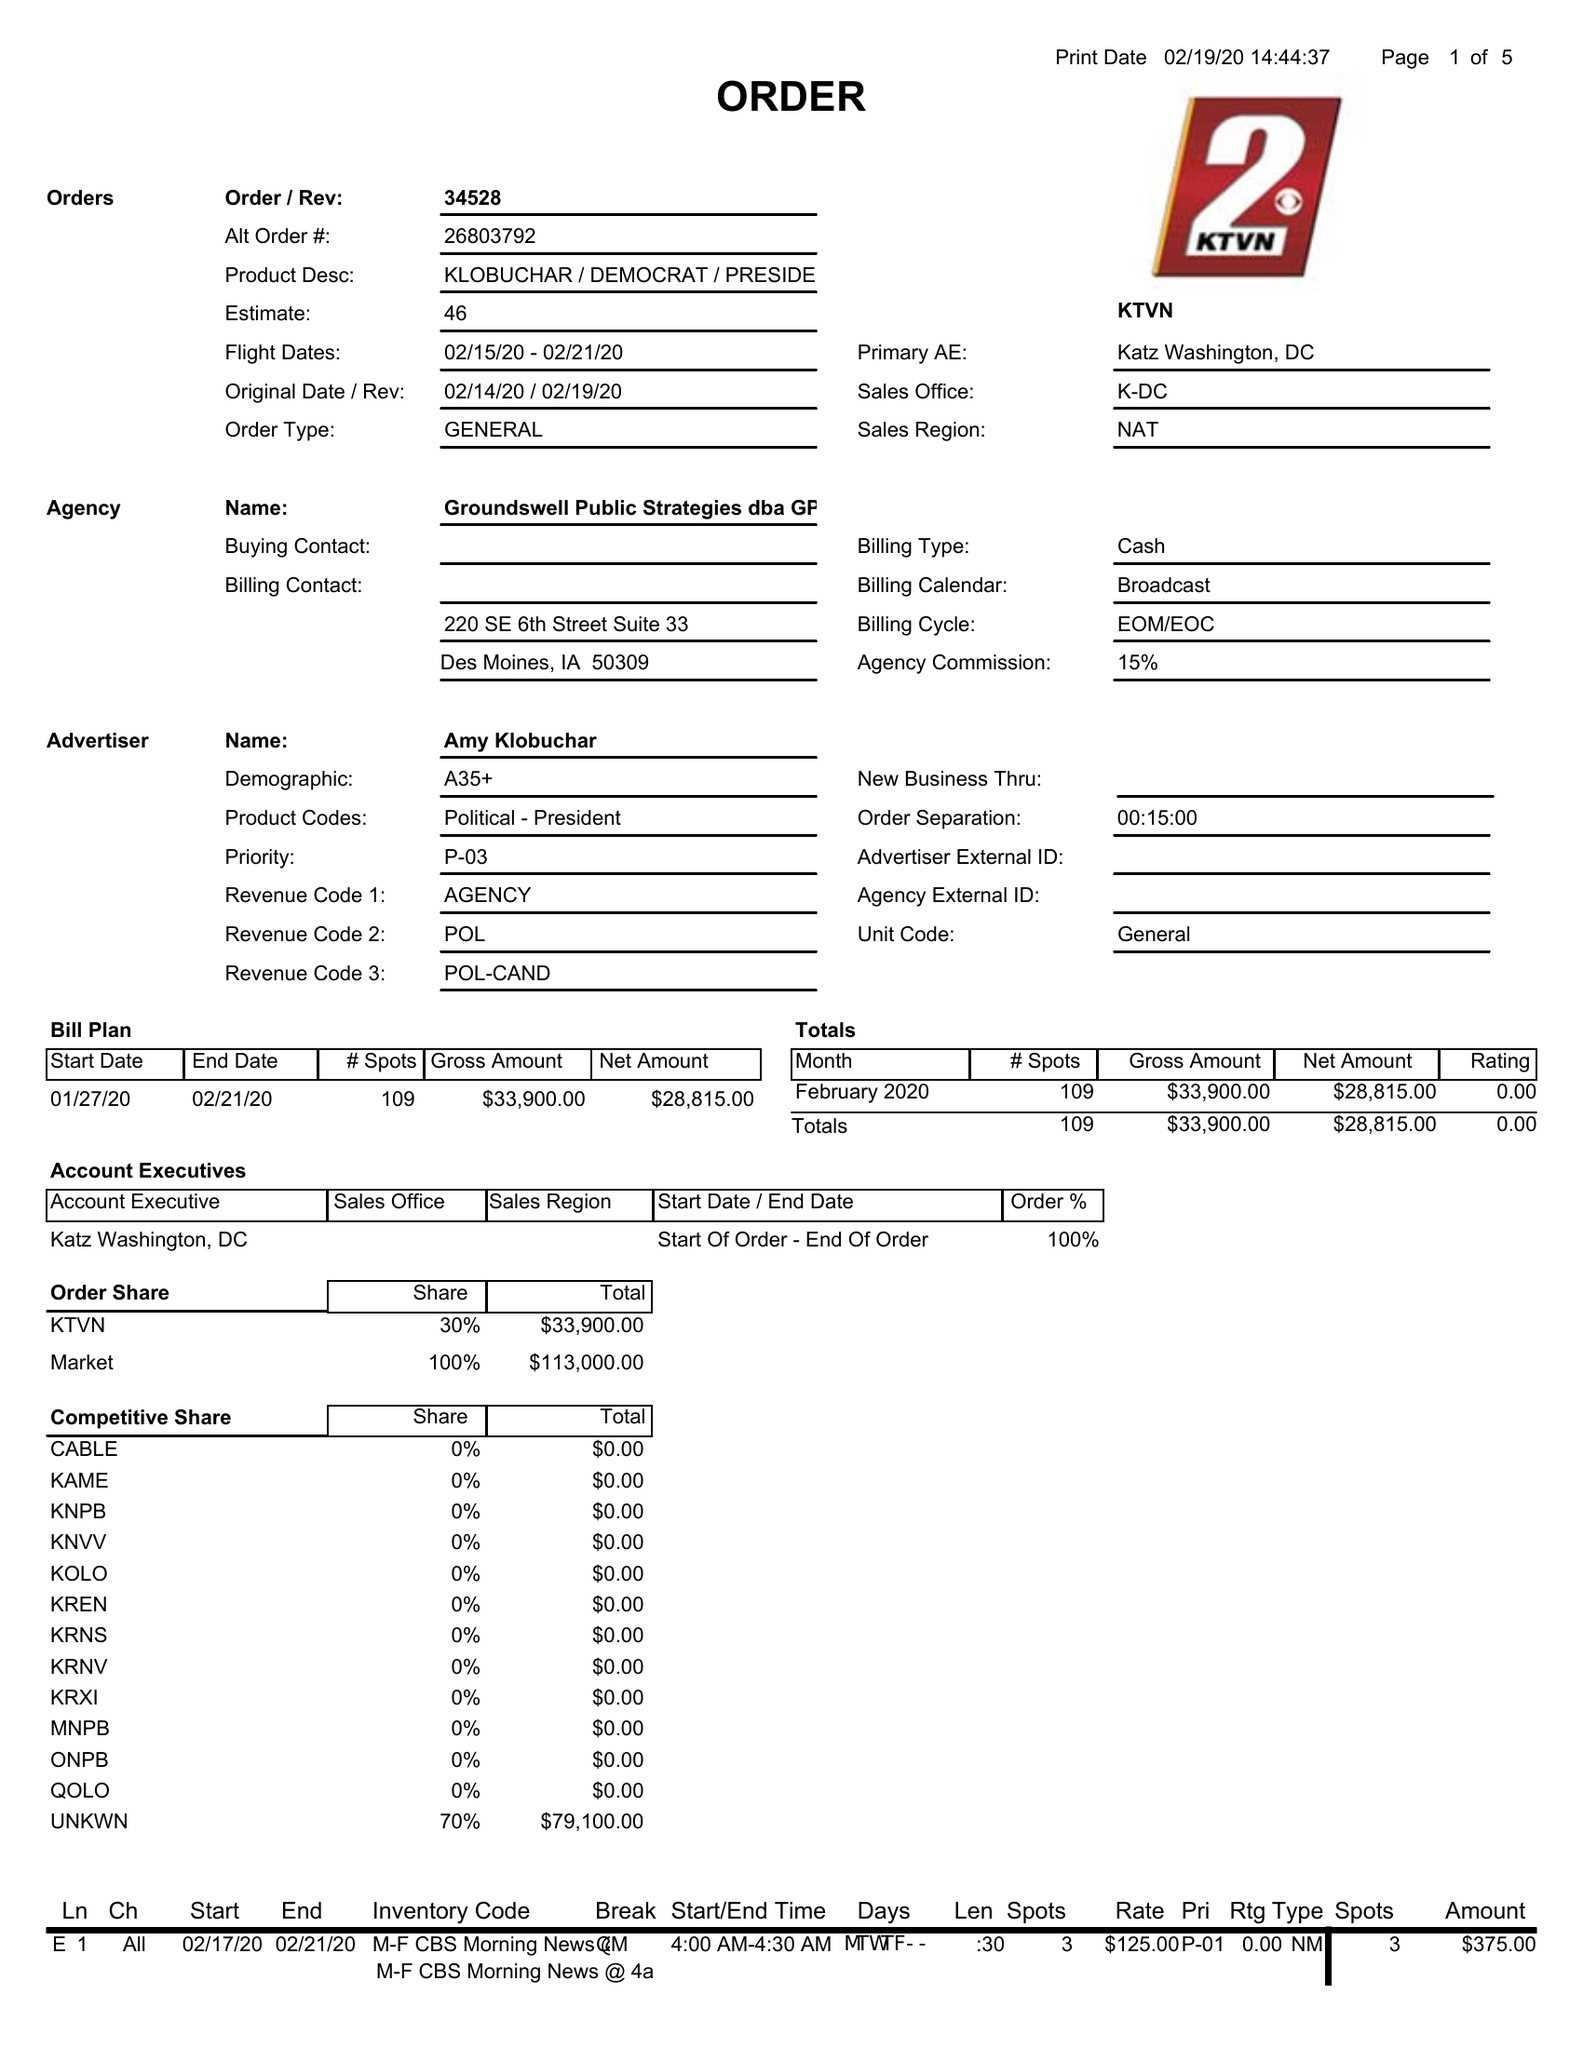What is the value for the flight_from?
Answer the question using a single word or phrase. 02/15/20 